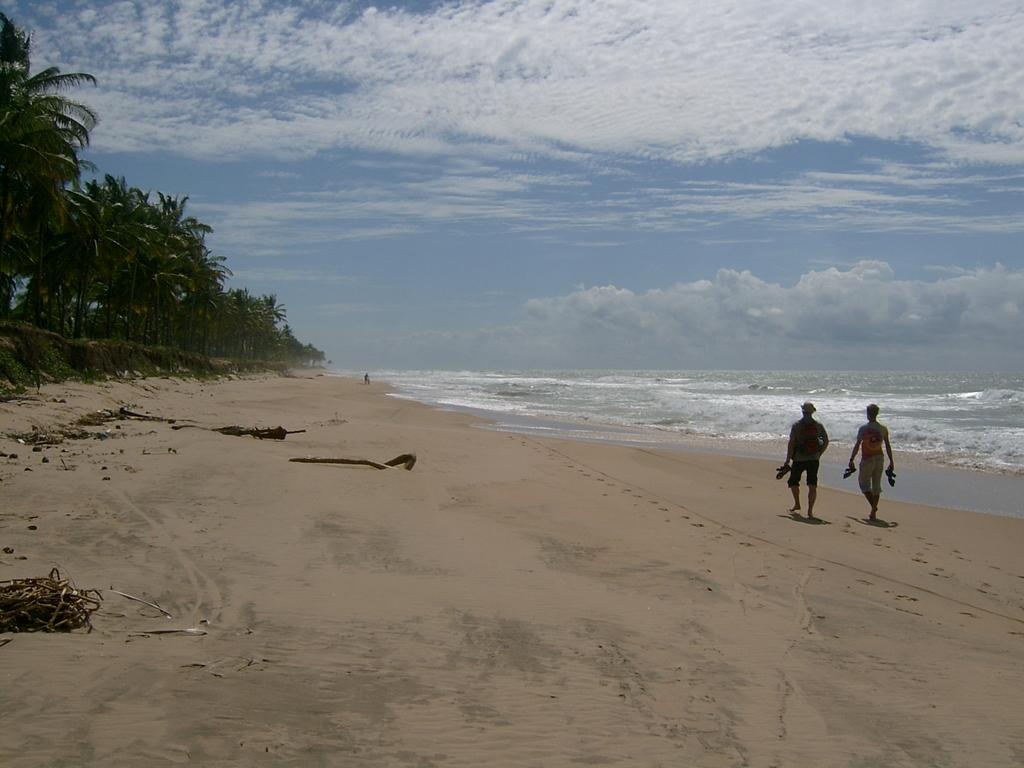How many people are in the image? There are two persons in the image. What are the persons doing in the image? The persons are walking. What are the persons holding in the image? The persons are holding an object. What can be seen in the background of the image? There are trees and water visible in the background of the image. What is the color of the trees in the background? The trees are green. What is the color of the sky in the image? The sky is blue and white in color. What type of coach can be seen in the image? There is no coach present in the image. Is the night sky visible in the image? No, the sky is blue and white in color, which indicates that it is daytime, not nighttime. --- Facts: 1. There is a car in the image. 2. The car is red. 3. The car has four wheels. 4. There are people in the car. 5. The car has a license plate. 6. The license plate has numbers and letters. Absurd Topics: parrot, sand, volcano Conversation: What is the main subject of the image? The main subject of the image is a car. What color is the car? The car is red. How many wheels does the car have? The car has four wheels. Are there any passengers in the car? Yes, there are people in the car. What can be seen on the car's exterior? The car has a license plate. What information is displayed on the license plate? The license plate has numbers and letters. Reasoning: Let's think step by step in order to produce the conversation. We start by identifying the main subject of the image, which is the car. Then, we describe the car's characteristics, such as its color and the number of wheels. Next, we mention the presence of passengers and the license plate. Finally, we provide details about the license plate, specifically the information displayed on it. Absurd Question/Answer: Can you see a parrot sitting on the car's roof in the image? No, there is no parrot present in the image. Is the car driving on a sandy beach in the image? No, there is no indication of a sandy beach in the image. 